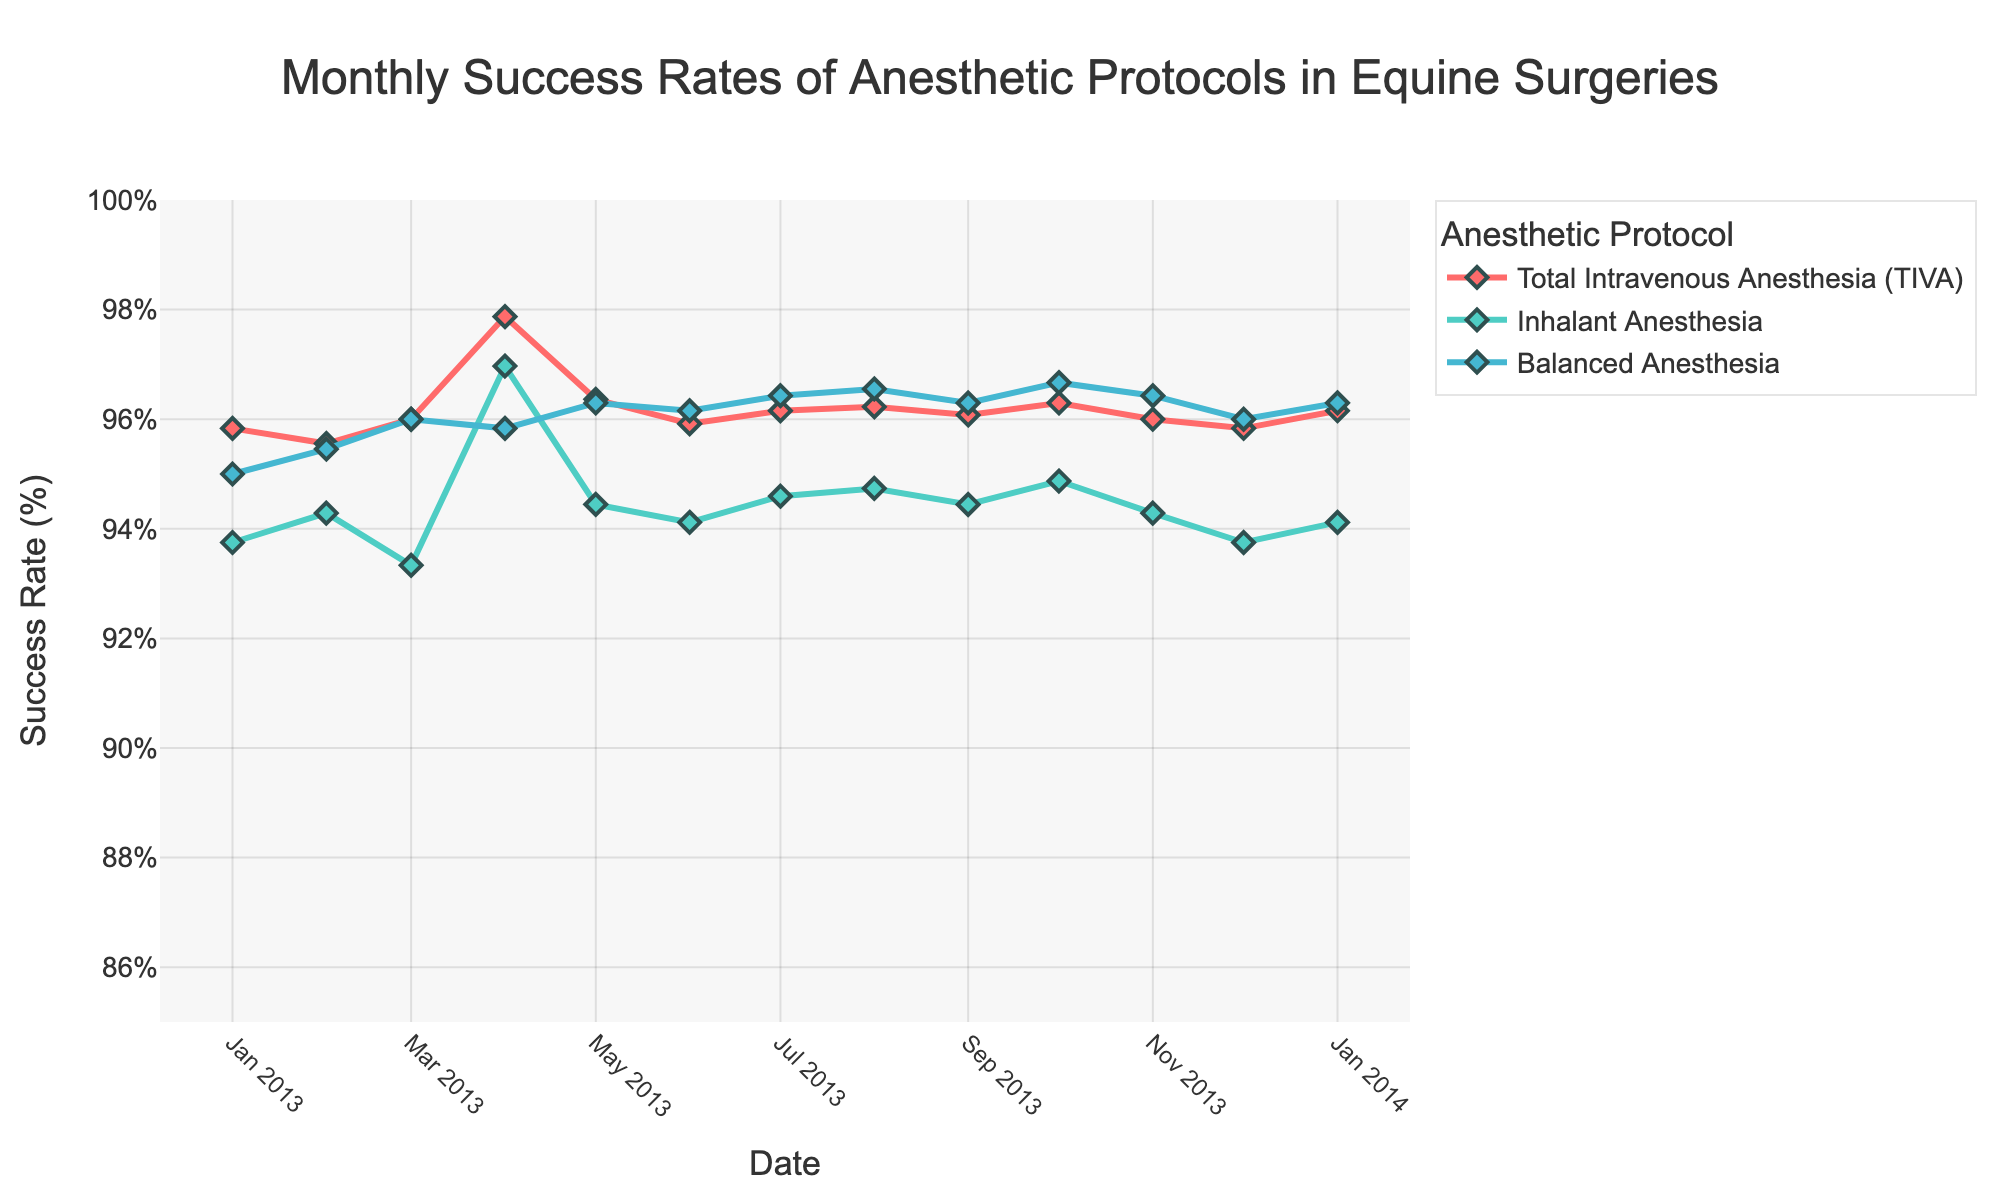Which month showed the highest success rate for Total Intravenous Anesthesia (TIVA) in 2013? By scanning the TIVA success rates for each month in 2013, the month with the highest rate can be identified. May 2013 showed the highest success rate.
Answer: May 2013 Which anesthetic protocol had the overall highest success rate in January 2014? Check the success rates of each protocol in January 2014. TIVA had a success rate of 96.2%, Inhalant Anesthesia had 94.1%, and Balanced Anesthesia had 96.3%. Balanced Anesthesia had the highest rate.
Answer: Balanced Anesthesia How did the success rate of Inhalant Anesthesia compare between January 2013 and January 2014? Observe the success rates of Inhalant Anesthesia for the two months. January 2013 had 93.8% and January 2014 had 94.1%. The success rate slightly increased in January 2014.
Answer: Increased Which protocol demonstrated the most consistent success rates throughout 2013? Look at the success rates of each protocol throughout 2013. TIVA and Balanced Anesthesia vary slightly but remain high, whereas Inhalant Anesthesia shows more fluctuation. TIVA shows more consistency.
Answer: TIVA What is the trend for the success rates of Balanced Anesthesia over the months in 2013? Review the trend line for Balanced Anesthesia over the months of 2013. The success rate gradually increases over the months.
Answer: Gradually increasing What was the lowest success rate recorded for any protocol in 2013, and which protocol was it? Check the lowest success rate for each protocol throughout 2013. All protocols maintain high success rates, but Inhalant Anesthesia had the lowest at 93.8% in several months.
Answer: 93.8%, Inhalant Anesthesia In which month did TIVA experience a slight drop in success rate compared to the previous month? (2013 data) Track the success rates month-to-month for TIVA in 2013. The success rate dropped slightly from March 2013 (96%) to April 2013 (97.9%).
Answer: April 2013 Which protocol had the largest difference in success rates between any two consecutive months in 2013? Examine the month-to-month success rates for each protocol and calculate the differences. Balanced Anesthesia saw the largest drop from June to July.
Answer: Balanced Anesthesia How often did the success rate of Balanced Anesthesia exceed 96% in 2013? Identify and count the instances where Balanced Anesthesia's success rate was above 96% during 2013 months. It exceeded 96% once.
Answer: Once Does any month show a simultaneous increase in success rate for all three protocols compared to the previous month? Compare the success rates of all three protocols month-by-month. In October 2013, all three protocols showed simultaneous increases.
Answer: October 2013 